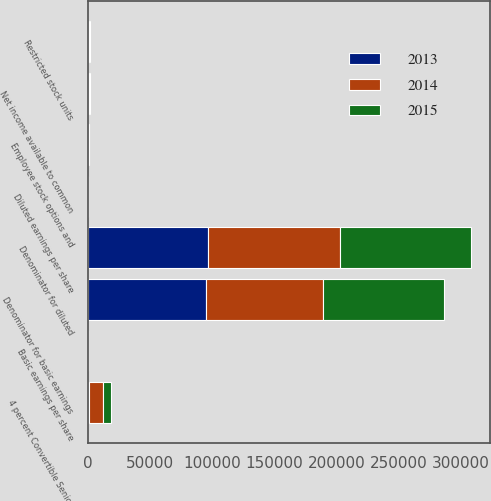Convert chart to OTSL. <chart><loc_0><loc_0><loc_500><loc_500><stacked_bar_chart><ecel><fcel>Net income available to common<fcel>Denominator for basic earnings<fcel>Employee stock options and<fcel>4 percent Convertible Senior<fcel>Restricted stock units<fcel>Denominator for diluted<fcel>Basic earnings per share<fcel>Diluted earnings per share<nl><fcel>2013<fcel>585<fcel>95170<fcel>300<fcel>660<fcel>249<fcel>96379<fcel>6.14<fcel>6.07<nl><fcel>2015<fcel>540<fcel>97489<fcel>394<fcel>6386<fcel>687<fcel>104956<fcel>5.54<fcel>5.15<nl><fcel>2014<fcel>387<fcel>93436<fcel>504<fcel>11769<fcel>582<fcel>106291<fcel>4.14<fcel>3.64<nl></chart> 